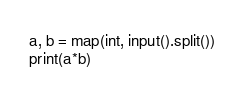<code> <loc_0><loc_0><loc_500><loc_500><_Python_>a, b = map(int, input().split())
print(a*b)
</code> 